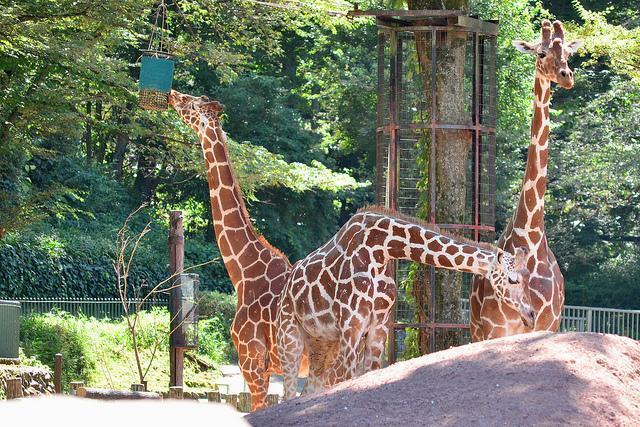How many giraffes are there?
Give a very brief answer. 3. How many giraffes can be seen?
Give a very brief answer. 3. 